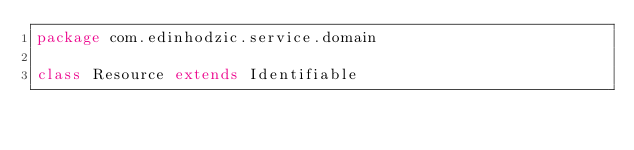<code> <loc_0><loc_0><loc_500><loc_500><_Scala_>package com.edinhodzic.service.domain

class Resource extends Identifiable
</code> 